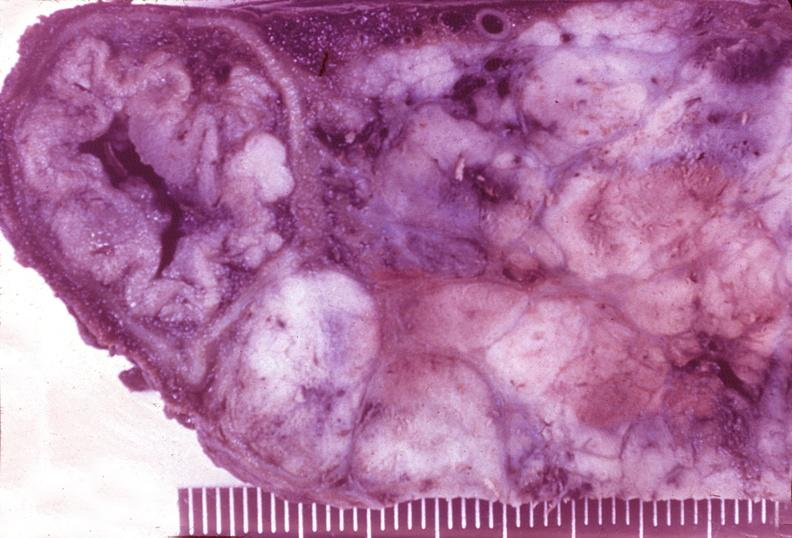what is present?
Answer the question using a single word or phrase. Pancreas 